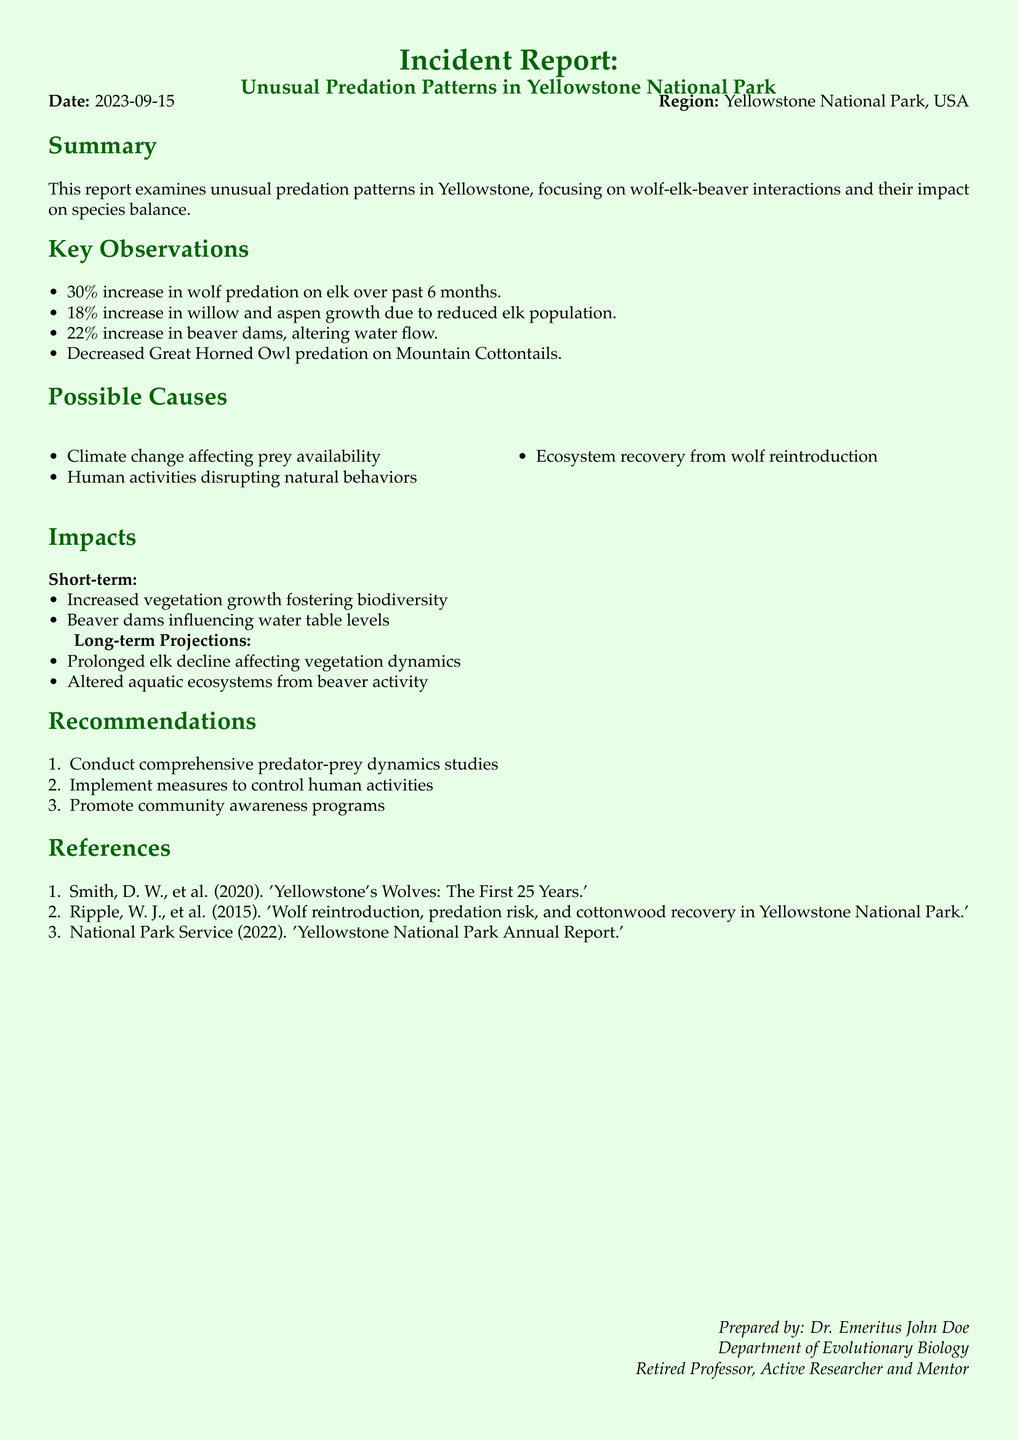What is the date of the report? The date of the report is mentioned at the beginning of the document.
Answer: 2023-09-15 What region is covered in the incident report? The report specifies the region being addressed right after the date.
Answer: Yellowstone National Park, USA What percentage increase in wolf predation on elk was observed? The document lists key observations, one of which is the specific increase in wolf predation on elk.
Answer: 30% What has been the percentage increase in beaver dams? The report includes this statistic within the key observations section.
Answer: 22% What are the short-term impacts mentioned in the report? The document outlines specific impacts under different headings, providing details about short-term effects.
Answer: Increased vegetation growth fostering biodiversity Which human activities are suggested to be controlled? The recommendations section hints at addressing human activities as a factor influencing the ecosystem.
Answer: Human activities disrupting natural behaviors What are the long-term projections regarding elk populations? The long-term projections outline potential consequences of changes in elk populations on vegetation dynamics.
Answer: Prolonged elk decline affecting vegetation dynamics What aspect of the ecosystem is influenced by beaver dams? The impact section discusses how beaver activity can alter certain environmental elements.
Answer: Water table levels Who prepared this incident report? The author's information is provided at the end of the document.
Answer: Dr. Emeritus John Doe 